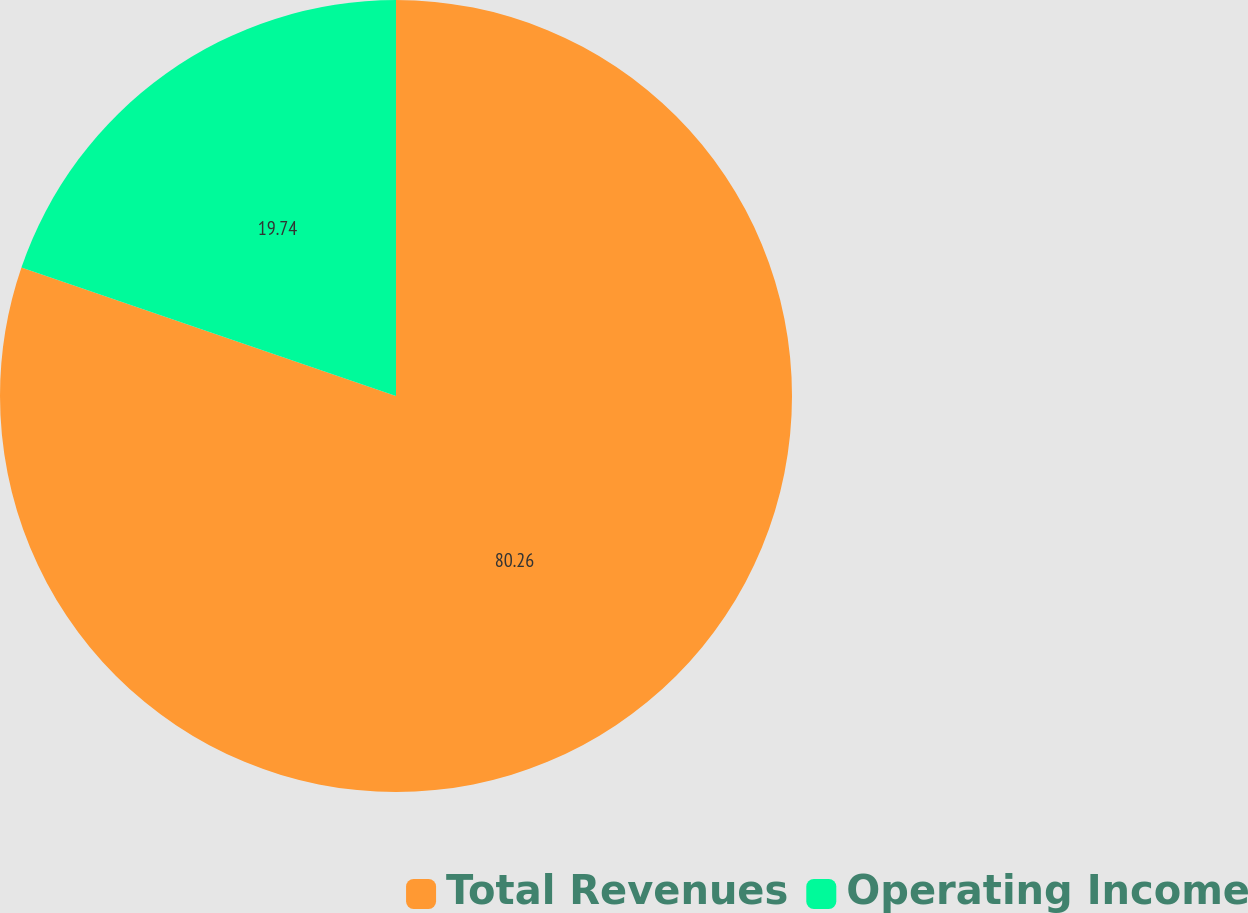Convert chart. <chart><loc_0><loc_0><loc_500><loc_500><pie_chart><fcel>Total Revenues<fcel>Operating Income<nl><fcel>80.26%<fcel>19.74%<nl></chart> 